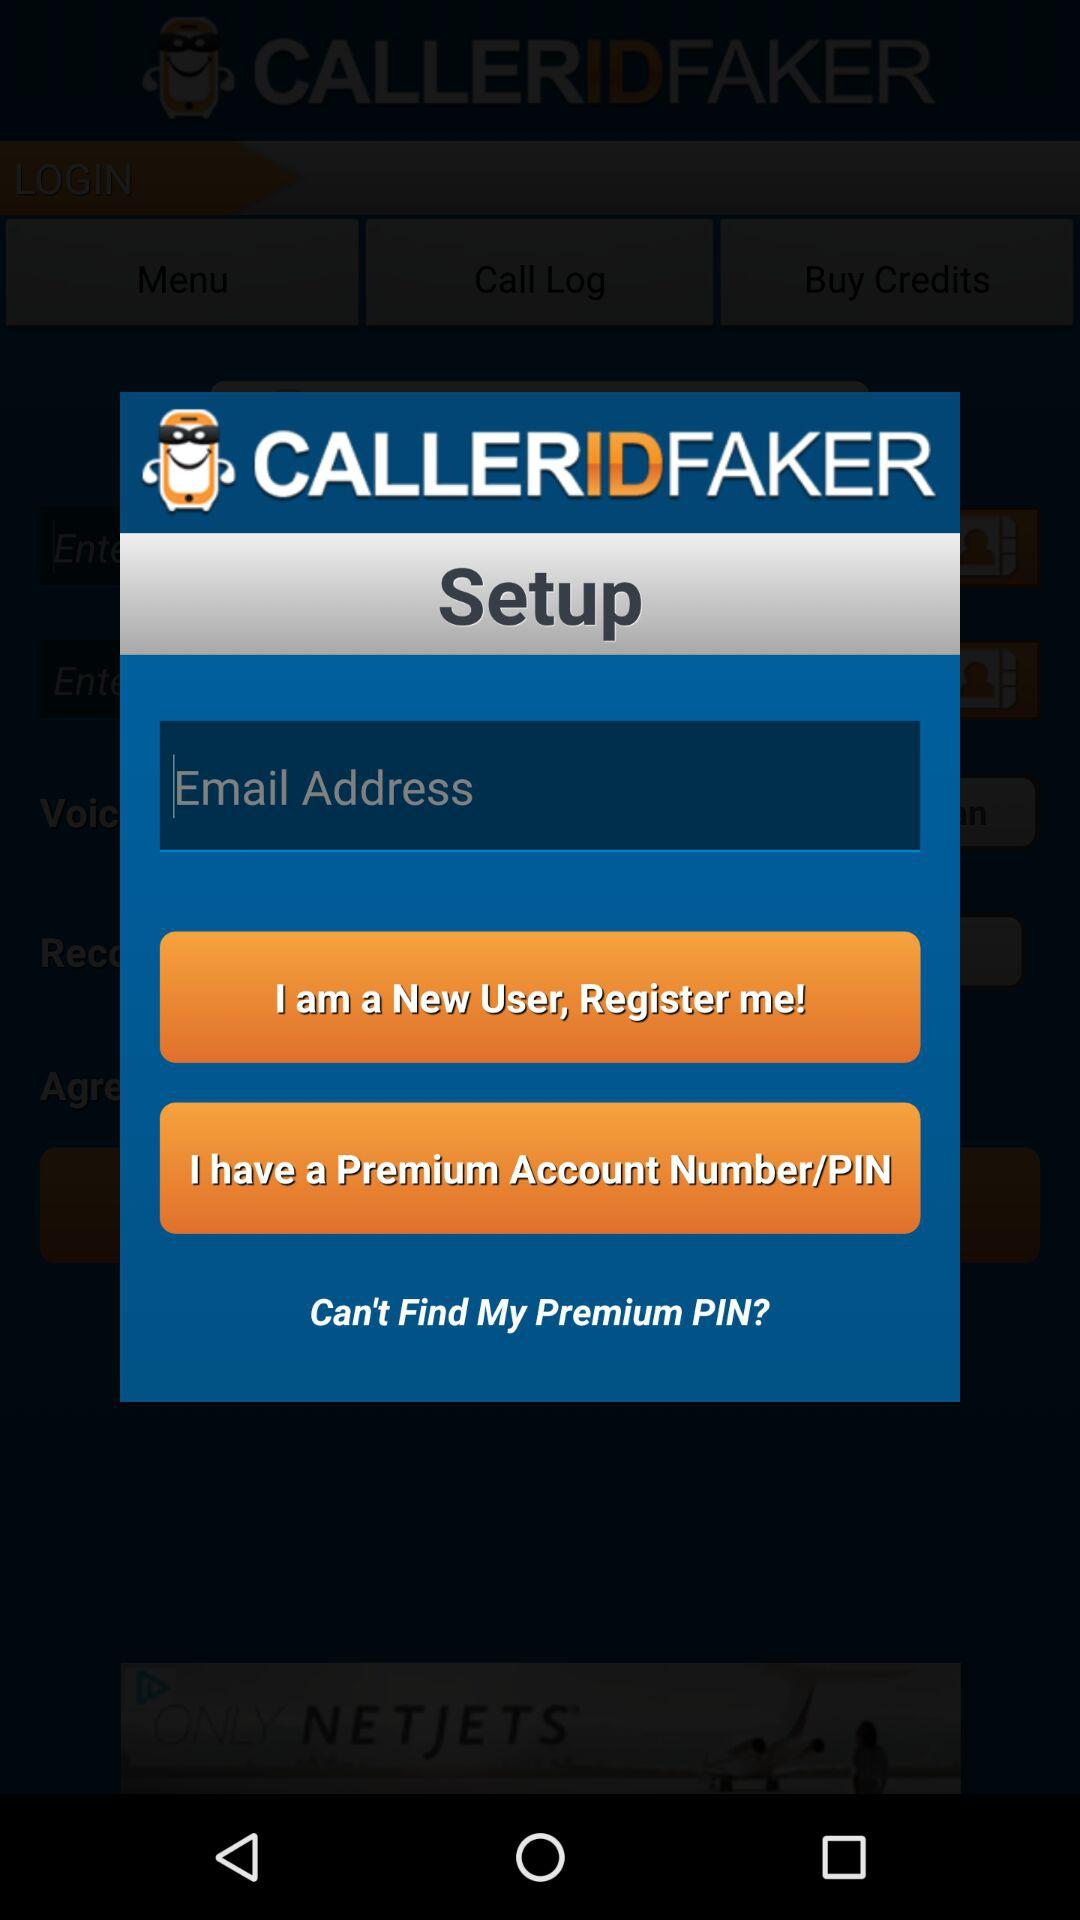What is the name of the application? The name of the application is "CALLERIDFAKER". 